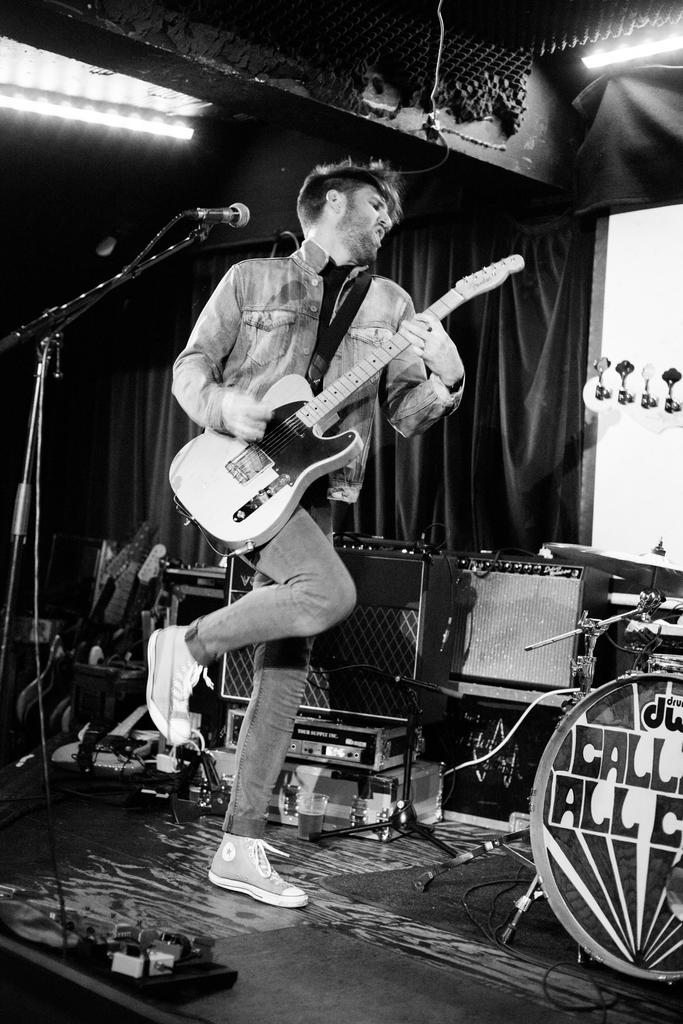What is the person in the image doing? The person is playing a guitar. What is in front of the person? There is a microphone in front of the person. What can be seen behind the person? There are boxes and curtains behind the person. What type of chin is visible in the image? There is no chin visible in the image; it is a person playing a guitar, and their face is not shown. 